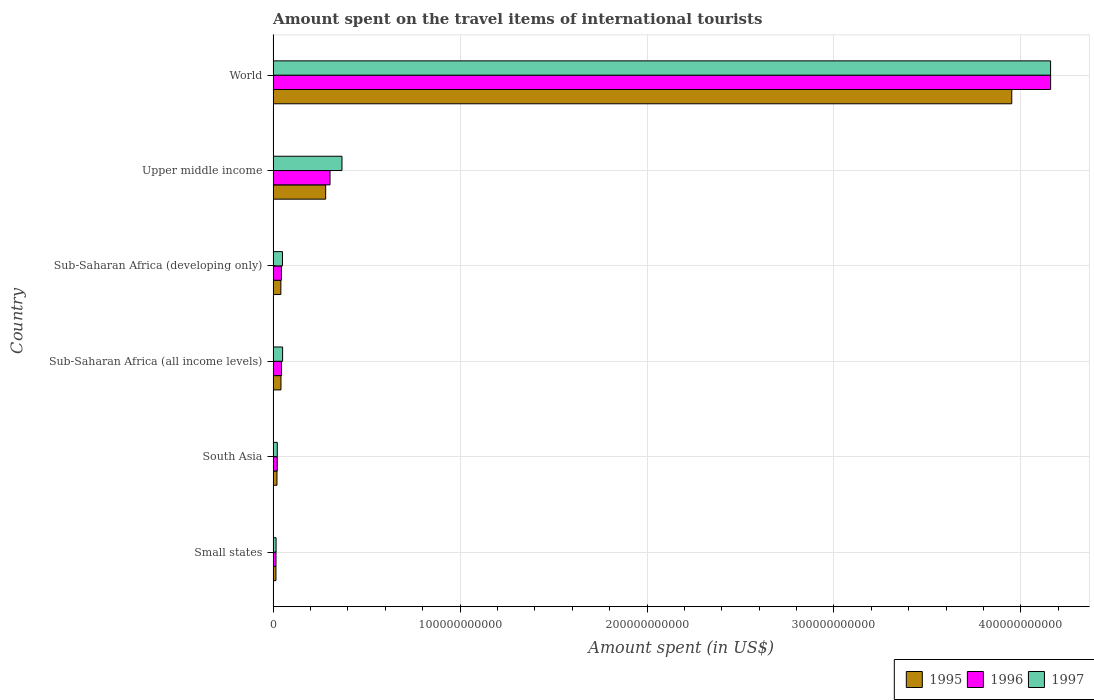How many different coloured bars are there?
Keep it short and to the point. 3. How many groups of bars are there?
Offer a very short reply. 6. Are the number of bars per tick equal to the number of legend labels?
Offer a very short reply. Yes. Are the number of bars on each tick of the Y-axis equal?
Keep it short and to the point. Yes. How many bars are there on the 1st tick from the bottom?
Offer a very short reply. 3. What is the label of the 2nd group of bars from the top?
Offer a terse response. Upper middle income. In how many cases, is the number of bars for a given country not equal to the number of legend labels?
Ensure brevity in your answer.  0. What is the amount spent on the travel items of international tourists in 1996 in World?
Provide a succinct answer. 4.16e+11. Across all countries, what is the maximum amount spent on the travel items of international tourists in 1997?
Offer a terse response. 4.16e+11. Across all countries, what is the minimum amount spent on the travel items of international tourists in 1997?
Your response must be concise. 1.58e+09. In which country was the amount spent on the travel items of international tourists in 1996 maximum?
Your response must be concise. World. In which country was the amount spent on the travel items of international tourists in 1996 minimum?
Make the answer very short. Small states. What is the total amount spent on the travel items of international tourists in 1997 in the graph?
Offer a terse response. 4.67e+11. What is the difference between the amount spent on the travel items of international tourists in 1996 in Small states and that in Sub-Saharan Africa (all income levels)?
Offer a very short reply. -2.96e+09. What is the difference between the amount spent on the travel items of international tourists in 1996 in South Asia and the amount spent on the travel items of international tourists in 1997 in World?
Provide a succinct answer. -4.14e+11. What is the average amount spent on the travel items of international tourists in 1996 per country?
Provide a succinct answer. 7.65e+1. What is the difference between the amount spent on the travel items of international tourists in 1995 and amount spent on the travel items of international tourists in 1996 in Upper middle income?
Your answer should be compact. -2.34e+09. In how many countries, is the amount spent on the travel items of international tourists in 1997 greater than 120000000000 US$?
Your answer should be very brief. 1. What is the ratio of the amount spent on the travel items of international tourists in 1997 in South Asia to that in Upper middle income?
Provide a succinct answer. 0.06. Is the amount spent on the travel items of international tourists in 1995 in South Asia less than that in Sub-Saharan Africa (all income levels)?
Your answer should be compact. Yes. Is the difference between the amount spent on the travel items of international tourists in 1995 in Sub-Saharan Africa (all income levels) and Upper middle income greater than the difference between the amount spent on the travel items of international tourists in 1996 in Sub-Saharan Africa (all income levels) and Upper middle income?
Keep it short and to the point. Yes. What is the difference between the highest and the second highest amount spent on the travel items of international tourists in 1997?
Offer a very short reply. 3.79e+11. What is the difference between the highest and the lowest amount spent on the travel items of international tourists in 1996?
Provide a succinct answer. 4.14e+11. Is the sum of the amount spent on the travel items of international tourists in 1997 in South Asia and World greater than the maximum amount spent on the travel items of international tourists in 1996 across all countries?
Your response must be concise. Yes. How many bars are there?
Provide a short and direct response. 18. How many countries are there in the graph?
Offer a very short reply. 6. What is the difference between two consecutive major ticks on the X-axis?
Your answer should be very brief. 1.00e+11. Are the values on the major ticks of X-axis written in scientific E-notation?
Offer a terse response. No. Does the graph contain grids?
Your answer should be very brief. Yes. How many legend labels are there?
Your answer should be compact. 3. How are the legend labels stacked?
Provide a succinct answer. Horizontal. What is the title of the graph?
Your answer should be very brief. Amount spent on the travel items of international tourists. Does "1998" appear as one of the legend labels in the graph?
Give a very brief answer. No. What is the label or title of the X-axis?
Offer a terse response. Amount spent (in US$). What is the Amount spent (in US$) in 1995 in Small states?
Provide a succinct answer. 1.51e+09. What is the Amount spent (in US$) in 1996 in Small states?
Provide a short and direct response. 1.54e+09. What is the Amount spent (in US$) of 1997 in Small states?
Provide a short and direct response. 1.58e+09. What is the Amount spent (in US$) of 1995 in South Asia?
Give a very brief answer. 2.06e+09. What is the Amount spent (in US$) in 1996 in South Asia?
Provide a short and direct response. 2.21e+09. What is the Amount spent (in US$) of 1997 in South Asia?
Offer a terse response. 2.23e+09. What is the Amount spent (in US$) of 1995 in Sub-Saharan Africa (all income levels)?
Ensure brevity in your answer.  4.20e+09. What is the Amount spent (in US$) in 1996 in Sub-Saharan Africa (all income levels)?
Provide a succinct answer. 4.50e+09. What is the Amount spent (in US$) in 1997 in Sub-Saharan Africa (all income levels)?
Your answer should be compact. 5.07e+09. What is the Amount spent (in US$) of 1995 in Sub-Saharan Africa (developing only)?
Offer a terse response. 4.14e+09. What is the Amount spent (in US$) in 1996 in Sub-Saharan Africa (developing only)?
Provide a short and direct response. 4.44e+09. What is the Amount spent (in US$) in 1997 in Sub-Saharan Africa (developing only)?
Offer a very short reply. 5.01e+09. What is the Amount spent (in US$) in 1995 in Upper middle income?
Offer a very short reply. 2.81e+1. What is the Amount spent (in US$) of 1996 in Upper middle income?
Offer a terse response. 3.04e+1. What is the Amount spent (in US$) of 1997 in Upper middle income?
Offer a terse response. 3.68e+1. What is the Amount spent (in US$) of 1995 in World?
Your answer should be compact. 3.95e+11. What is the Amount spent (in US$) of 1996 in World?
Offer a very short reply. 4.16e+11. What is the Amount spent (in US$) in 1997 in World?
Give a very brief answer. 4.16e+11. Across all countries, what is the maximum Amount spent (in US$) of 1995?
Provide a short and direct response. 3.95e+11. Across all countries, what is the maximum Amount spent (in US$) in 1996?
Offer a very short reply. 4.16e+11. Across all countries, what is the maximum Amount spent (in US$) in 1997?
Your response must be concise. 4.16e+11. Across all countries, what is the minimum Amount spent (in US$) in 1995?
Provide a short and direct response. 1.51e+09. Across all countries, what is the minimum Amount spent (in US$) in 1996?
Provide a succinct answer. 1.54e+09. Across all countries, what is the minimum Amount spent (in US$) of 1997?
Keep it short and to the point. 1.58e+09. What is the total Amount spent (in US$) in 1995 in the graph?
Keep it short and to the point. 4.35e+11. What is the total Amount spent (in US$) of 1996 in the graph?
Make the answer very short. 4.59e+11. What is the total Amount spent (in US$) in 1997 in the graph?
Ensure brevity in your answer.  4.67e+11. What is the difference between the Amount spent (in US$) of 1995 in Small states and that in South Asia?
Give a very brief answer. -5.48e+08. What is the difference between the Amount spent (in US$) of 1996 in Small states and that in South Asia?
Provide a short and direct response. -6.72e+08. What is the difference between the Amount spent (in US$) of 1997 in Small states and that in South Asia?
Make the answer very short. -6.45e+08. What is the difference between the Amount spent (in US$) in 1995 in Small states and that in Sub-Saharan Africa (all income levels)?
Your answer should be very brief. -2.69e+09. What is the difference between the Amount spent (in US$) of 1996 in Small states and that in Sub-Saharan Africa (all income levels)?
Provide a succinct answer. -2.96e+09. What is the difference between the Amount spent (in US$) in 1997 in Small states and that in Sub-Saharan Africa (all income levels)?
Your answer should be very brief. -3.49e+09. What is the difference between the Amount spent (in US$) in 1995 in Small states and that in Sub-Saharan Africa (developing only)?
Give a very brief answer. -2.63e+09. What is the difference between the Amount spent (in US$) of 1996 in Small states and that in Sub-Saharan Africa (developing only)?
Provide a short and direct response. -2.90e+09. What is the difference between the Amount spent (in US$) in 1997 in Small states and that in Sub-Saharan Africa (developing only)?
Your answer should be compact. -3.42e+09. What is the difference between the Amount spent (in US$) of 1995 in Small states and that in Upper middle income?
Your answer should be compact. -2.66e+1. What is the difference between the Amount spent (in US$) in 1996 in Small states and that in Upper middle income?
Provide a succinct answer. -2.89e+1. What is the difference between the Amount spent (in US$) of 1997 in Small states and that in Upper middle income?
Give a very brief answer. -3.53e+1. What is the difference between the Amount spent (in US$) in 1995 in Small states and that in World?
Give a very brief answer. -3.94e+11. What is the difference between the Amount spent (in US$) in 1996 in Small states and that in World?
Offer a very short reply. -4.14e+11. What is the difference between the Amount spent (in US$) of 1997 in Small states and that in World?
Your response must be concise. -4.14e+11. What is the difference between the Amount spent (in US$) of 1995 in South Asia and that in Sub-Saharan Africa (all income levels)?
Give a very brief answer. -2.14e+09. What is the difference between the Amount spent (in US$) of 1996 in South Asia and that in Sub-Saharan Africa (all income levels)?
Provide a short and direct response. -2.29e+09. What is the difference between the Amount spent (in US$) of 1997 in South Asia and that in Sub-Saharan Africa (all income levels)?
Your answer should be compact. -2.85e+09. What is the difference between the Amount spent (in US$) in 1995 in South Asia and that in Sub-Saharan Africa (developing only)?
Keep it short and to the point. -2.08e+09. What is the difference between the Amount spent (in US$) in 1996 in South Asia and that in Sub-Saharan Africa (developing only)?
Offer a very short reply. -2.23e+09. What is the difference between the Amount spent (in US$) of 1997 in South Asia and that in Sub-Saharan Africa (developing only)?
Your answer should be very brief. -2.78e+09. What is the difference between the Amount spent (in US$) of 1995 in South Asia and that in Upper middle income?
Make the answer very short. -2.61e+1. What is the difference between the Amount spent (in US$) of 1996 in South Asia and that in Upper middle income?
Your answer should be compact. -2.82e+1. What is the difference between the Amount spent (in US$) in 1997 in South Asia and that in Upper middle income?
Your answer should be compact. -3.46e+1. What is the difference between the Amount spent (in US$) in 1995 in South Asia and that in World?
Provide a succinct answer. -3.93e+11. What is the difference between the Amount spent (in US$) of 1996 in South Asia and that in World?
Provide a succinct answer. -4.14e+11. What is the difference between the Amount spent (in US$) in 1997 in South Asia and that in World?
Provide a short and direct response. -4.14e+11. What is the difference between the Amount spent (in US$) in 1995 in Sub-Saharan Africa (all income levels) and that in Sub-Saharan Africa (developing only)?
Provide a short and direct response. 5.93e+07. What is the difference between the Amount spent (in US$) of 1996 in Sub-Saharan Africa (all income levels) and that in Sub-Saharan Africa (developing only)?
Your answer should be very brief. 6.18e+07. What is the difference between the Amount spent (in US$) of 1997 in Sub-Saharan Africa (all income levels) and that in Sub-Saharan Africa (developing only)?
Offer a terse response. 6.67e+07. What is the difference between the Amount spent (in US$) of 1995 in Sub-Saharan Africa (all income levels) and that in Upper middle income?
Provide a succinct answer. -2.39e+1. What is the difference between the Amount spent (in US$) in 1996 in Sub-Saharan Africa (all income levels) and that in Upper middle income?
Offer a very short reply. -2.59e+1. What is the difference between the Amount spent (in US$) of 1997 in Sub-Saharan Africa (all income levels) and that in Upper middle income?
Keep it short and to the point. -3.18e+1. What is the difference between the Amount spent (in US$) of 1995 in Sub-Saharan Africa (all income levels) and that in World?
Your answer should be very brief. -3.91e+11. What is the difference between the Amount spent (in US$) in 1996 in Sub-Saharan Africa (all income levels) and that in World?
Make the answer very short. -4.11e+11. What is the difference between the Amount spent (in US$) of 1997 in Sub-Saharan Africa (all income levels) and that in World?
Offer a terse response. -4.11e+11. What is the difference between the Amount spent (in US$) of 1995 in Sub-Saharan Africa (developing only) and that in Upper middle income?
Your answer should be very brief. -2.40e+1. What is the difference between the Amount spent (in US$) in 1996 in Sub-Saharan Africa (developing only) and that in Upper middle income?
Ensure brevity in your answer.  -2.60e+1. What is the difference between the Amount spent (in US$) of 1997 in Sub-Saharan Africa (developing only) and that in Upper middle income?
Give a very brief answer. -3.18e+1. What is the difference between the Amount spent (in US$) in 1995 in Sub-Saharan Africa (developing only) and that in World?
Keep it short and to the point. -3.91e+11. What is the difference between the Amount spent (in US$) in 1996 in Sub-Saharan Africa (developing only) and that in World?
Keep it short and to the point. -4.11e+11. What is the difference between the Amount spent (in US$) of 1997 in Sub-Saharan Africa (developing only) and that in World?
Give a very brief answer. -4.11e+11. What is the difference between the Amount spent (in US$) in 1995 in Upper middle income and that in World?
Keep it short and to the point. -3.67e+11. What is the difference between the Amount spent (in US$) in 1996 in Upper middle income and that in World?
Your answer should be very brief. -3.85e+11. What is the difference between the Amount spent (in US$) in 1997 in Upper middle income and that in World?
Offer a very short reply. -3.79e+11. What is the difference between the Amount spent (in US$) in 1995 in Small states and the Amount spent (in US$) in 1996 in South Asia?
Keep it short and to the point. -7.03e+08. What is the difference between the Amount spent (in US$) of 1995 in Small states and the Amount spent (in US$) of 1997 in South Asia?
Provide a succinct answer. -7.17e+08. What is the difference between the Amount spent (in US$) of 1996 in Small states and the Amount spent (in US$) of 1997 in South Asia?
Your response must be concise. -6.86e+08. What is the difference between the Amount spent (in US$) in 1995 in Small states and the Amount spent (in US$) in 1996 in Sub-Saharan Africa (all income levels)?
Your response must be concise. -2.99e+09. What is the difference between the Amount spent (in US$) of 1995 in Small states and the Amount spent (in US$) of 1997 in Sub-Saharan Africa (all income levels)?
Ensure brevity in your answer.  -3.56e+09. What is the difference between the Amount spent (in US$) in 1996 in Small states and the Amount spent (in US$) in 1997 in Sub-Saharan Africa (all income levels)?
Make the answer very short. -3.53e+09. What is the difference between the Amount spent (in US$) in 1995 in Small states and the Amount spent (in US$) in 1996 in Sub-Saharan Africa (developing only)?
Provide a succinct answer. -2.93e+09. What is the difference between the Amount spent (in US$) in 1995 in Small states and the Amount spent (in US$) in 1997 in Sub-Saharan Africa (developing only)?
Keep it short and to the point. -3.50e+09. What is the difference between the Amount spent (in US$) of 1996 in Small states and the Amount spent (in US$) of 1997 in Sub-Saharan Africa (developing only)?
Keep it short and to the point. -3.46e+09. What is the difference between the Amount spent (in US$) in 1995 in Small states and the Amount spent (in US$) in 1996 in Upper middle income?
Offer a very short reply. -2.89e+1. What is the difference between the Amount spent (in US$) in 1995 in Small states and the Amount spent (in US$) in 1997 in Upper middle income?
Ensure brevity in your answer.  -3.53e+1. What is the difference between the Amount spent (in US$) of 1996 in Small states and the Amount spent (in US$) of 1997 in Upper middle income?
Keep it short and to the point. -3.53e+1. What is the difference between the Amount spent (in US$) of 1995 in Small states and the Amount spent (in US$) of 1996 in World?
Offer a very short reply. -4.14e+11. What is the difference between the Amount spent (in US$) in 1995 in Small states and the Amount spent (in US$) in 1997 in World?
Give a very brief answer. -4.14e+11. What is the difference between the Amount spent (in US$) in 1996 in Small states and the Amount spent (in US$) in 1997 in World?
Offer a very short reply. -4.14e+11. What is the difference between the Amount spent (in US$) of 1995 in South Asia and the Amount spent (in US$) of 1996 in Sub-Saharan Africa (all income levels)?
Keep it short and to the point. -2.44e+09. What is the difference between the Amount spent (in US$) of 1995 in South Asia and the Amount spent (in US$) of 1997 in Sub-Saharan Africa (all income levels)?
Your response must be concise. -3.01e+09. What is the difference between the Amount spent (in US$) in 1996 in South Asia and the Amount spent (in US$) in 1997 in Sub-Saharan Africa (all income levels)?
Offer a terse response. -2.86e+09. What is the difference between the Amount spent (in US$) in 1995 in South Asia and the Amount spent (in US$) in 1996 in Sub-Saharan Africa (developing only)?
Offer a terse response. -2.38e+09. What is the difference between the Amount spent (in US$) in 1995 in South Asia and the Amount spent (in US$) in 1997 in Sub-Saharan Africa (developing only)?
Make the answer very short. -2.95e+09. What is the difference between the Amount spent (in US$) in 1996 in South Asia and the Amount spent (in US$) in 1997 in Sub-Saharan Africa (developing only)?
Your answer should be very brief. -2.79e+09. What is the difference between the Amount spent (in US$) of 1995 in South Asia and the Amount spent (in US$) of 1996 in Upper middle income?
Make the answer very short. -2.84e+1. What is the difference between the Amount spent (in US$) in 1995 in South Asia and the Amount spent (in US$) in 1997 in Upper middle income?
Make the answer very short. -3.48e+1. What is the difference between the Amount spent (in US$) in 1996 in South Asia and the Amount spent (in US$) in 1997 in Upper middle income?
Keep it short and to the point. -3.46e+1. What is the difference between the Amount spent (in US$) in 1995 in South Asia and the Amount spent (in US$) in 1996 in World?
Offer a very short reply. -4.14e+11. What is the difference between the Amount spent (in US$) of 1995 in South Asia and the Amount spent (in US$) of 1997 in World?
Ensure brevity in your answer.  -4.14e+11. What is the difference between the Amount spent (in US$) of 1996 in South Asia and the Amount spent (in US$) of 1997 in World?
Your response must be concise. -4.14e+11. What is the difference between the Amount spent (in US$) in 1995 in Sub-Saharan Africa (all income levels) and the Amount spent (in US$) in 1996 in Sub-Saharan Africa (developing only)?
Your answer should be very brief. -2.40e+08. What is the difference between the Amount spent (in US$) of 1995 in Sub-Saharan Africa (all income levels) and the Amount spent (in US$) of 1997 in Sub-Saharan Africa (developing only)?
Your response must be concise. -8.08e+08. What is the difference between the Amount spent (in US$) in 1996 in Sub-Saharan Africa (all income levels) and the Amount spent (in US$) in 1997 in Sub-Saharan Africa (developing only)?
Keep it short and to the point. -5.05e+08. What is the difference between the Amount spent (in US$) of 1995 in Sub-Saharan Africa (all income levels) and the Amount spent (in US$) of 1996 in Upper middle income?
Your answer should be very brief. -2.62e+1. What is the difference between the Amount spent (in US$) of 1995 in Sub-Saharan Africa (all income levels) and the Amount spent (in US$) of 1997 in Upper middle income?
Ensure brevity in your answer.  -3.26e+1. What is the difference between the Amount spent (in US$) of 1996 in Sub-Saharan Africa (all income levels) and the Amount spent (in US$) of 1997 in Upper middle income?
Your response must be concise. -3.23e+1. What is the difference between the Amount spent (in US$) of 1995 in Sub-Saharan Africa (all income levels) and the Amount spent (in US$) of 1996 in World?
Provide a succinct answer. -4.12e+11. What is the difference between the Amount spent (in US$) in 1995 in Sub-Saharan Africa (all income levels) and the Amount spent (in US$) in 1997 in World?
Your answer should be compact. -4.12e+11. What is the difference between the Amount spent (in US$) in 1996 in Sub-Saharan Africa (all income levels) and the Amount spent (in US$) in 1997 in World?
Your response must be concise. -4.11e+11. What is the difference between the Amount spent (in US$) in 1995 in Sub-Saharan Africa (developing only) and the Amount spent (in US$) in 1996 in Upper middle income?
Your answer should be very brief. -2.63e+1. What is the difference between the Amount spent (in US$) of 1995 in Sub-Saharan Africa (developing only) and the Amount spent (in US$) of 1997 in Upper middle income?
Ensure brevity in your answer.  -3.27e+1. What is the difference between the Amount spent (in US$) in 1996 in Sub-Saharan Africa (developing only) and the Amount spent (in US$) in 1997 in Upper middle income?
Make the answer very short. -3.24e+1. What is the difference between the Amount spent (in US$) of 1995 in Sub-Saharan Africa (developing only) and the Amount spent (in US$) of 1996 in World?
Offer a very short reply. -4.12e+11. What is the difference between the Amount spent (in US$) in 1995 in Sub-Saharan Africa (developing only) and the Amount spent (in US$) in 1997 in World?
Give a very brief answer. -4.12e+11. What is the difference between the Amount spent (in US$) of 1996 in Sub-Saharan Africa (developing only) and the Amount spent (in US$) of 1997 in World?
Provide a short and direct response. -4.11e+11. What is the difference between the Amount spent (in US$) in 1995 in Upper middle income and the Amount spent (in US$) in 1996 in World?
Make the answer very short. -3.88e+11. What is the difference between the Amount spent (in US$) in 1995 in Upper middle income and the Amount spent (in US$) in 1997 in World?
Ensure brevity in your answer.  -3.88e+11. What is the difference between the Amount spent (in US$) in 1996 in Upper middle income and the Amount spent (in US$) in 1997 in World?
Ensure brevity in your answer.  -3.85e+11. What is the average Amount spent (in US$) in 1995 per country?
Give a very brief answer. 7.25e+1. What is the average Amount spent (in US$) of 1996 per country?
Your answer should be compact. 7.65e+1. What is the average Amount spent (in US$) in 1997 per country?
Provide a succinct answer. 7.78e+1. What is the difference between the Amount spent (in US$) in 1995 and Amount spent (in US$) in 1996 in Small states?
Provide a short and direct response. -3.15e+07. What is the difference between the Amount spent (in US$) of 1995 and Amount spent (in US$) of 1997 in Small states?
Your response must be concise. -7.24e+07. What is the difference between the Amount spent (in US$) in 1996 and Amount spent (in US$) in 1997 in Small states?
Keep it short and to the point. -4.09e+07. What is the difference between the Amount spent (in US$) of 1995 and Amount spent (in US$) of 1996 in South Asia?
Offer a terse response. -1.55e+08. What is the difference between the Amount spent (in US$) of 1995 and Amount spent (in US$) of 1997 in South Asia?
Keep it short and to the point. -1.69e+08. What is the difference between the Amount spent (in US$) of 1996 and Amount spent (in US$) of 1997 in South Asia?
Provide a succinct answer. -1.42e+07. What is the difference between the Amount spent (in US$) of 1995 and Amount spent (in US$) of 1996 in Sub-Saharan Africa (all income levels)?
Make the answer very short. -3.02e+08. What is the difference between the Amount spent (in US$) in 1995 and Amount spent (in US$) in 1997 in Sub-Saharan Africa (all income levels)?
Keep it short and to the point. -8.74e+08. What is the difference between the Amount spent (in US$) in 1996 and Amount spent (in US$) in 1997 in Sub-Saharan Africa (all income levels)?
Ensure brevity in your answer.  -5.72e+08. What is the difference between the Amount spent (in US$) of 1995 and Amount spent (in US$) of 1996 in Sub-Saharan Africa (developing only)?
Your response must be concise. -3.00e+08. What is the difference between the Amount spent (in US$) of 1995 and Amount spent (in US$) of 1997 in Sub-Saharan Africa (developing only)?
Your answer should be very brief. -8.67e+08. What is the difference between the Amount spent (in US$) of 1996 and Amount spent (in US$) of 1997 in Sub-Saharan Africa (developing only)?
Your response must be concise. -5.67e+08. What is the difference between the Amount spent (in US$) in 1995 and Amount spent (in US$) in 1996 in Upper middle income?
Make the answer very short. -2.34e+09. What is the difference between the Amount spent (in US$) in 1995 and Amount spent (in US$) in 1997 in Upper middle income?
Offer a terse response. -8.72e+09. What is the difference between the Amount spent (in US$) of 1996 and Amount spent (in US$) of 1997 in Upper middle income?
Provide a succinct answer. -6.39e+09. What is the difference between the Amount spent (in US$) of 1995 and Amount spent (in US$) of 1996 in World?
Your answer should be very brief. -2.08e+1. What is the difference between the Amount spent (in US$) in 1995 and Amount spent (in US$) in 1997 in World?
Your answer should be very brief. -2.08e+1. What is the difference between the Amount spent (in US$) of 1996 and Amount spent (in US$) of 1997 in World?
Ensure brevity in your answer.  1.91e+07. What is the ratio of the Amount spent (in US$) of 1995 in Small states to that in South Asia?
Provide a short and direct response. 0.73. What is the ratio of the Amount spent (in US$) in 1996 in Small states to that in South Asia?
Ensure brevity in your answer.  0.7. What is the ratio of the Amount spent (in US$) of 1997 in Small states to that in South Asia?
Keep it short and to the point. 0.71. What is the ratio of the Amount spent (in US$) of 1995 in Small states to that in Sub-Saharan Africa (all income levels)?
Provide a short and direct response. 0.36. What is the ratio of the Amount spent (in US$) of 1996 in Small states to that in Sub-Saharan Africa (all income levels)?
Provide a succinct answer. 0.34. What is the ratio of the Amount spent (in US$) of 1997 in Small states to that in Sub-Saharan Africa (all income levels)?
Ensure brevity in your answer.  0.31. What is the ratio of the Amount spent (in US$) of 1995 in Small states to that in Sub-Saharan Africa (developing only)?
Your response must be concise. 0.36. What is the ratio of the Amount spent (in US$) of 1996 in Small states to that in Sub-Saharan Africa (developing only)?
Keep it short and to the point. 0.35. What is the ratio of the Amount spent (in US$) of 1997 in Small states to that in Sub-Saharan Africa (developing only)?
Offer a terse response. 0.32. What is the ratio of the Amount spent (in US$) in 1995 in Small states to that in Upper middle income?
Your answer should be very brief. 0.05. What is the ratio of the Amount spent (in US$) of 1996 in Small states to that in Upper middle income?
Keep it short and to the point. 0.05. What is the ratio of the Amount spent (in US$) of 1997 in Small states to that in Upper middle income?
Provide a succinct answer. 0.04. What is the ratio of the Amount spent (in US$) in 1995 in Small states to that in World?
Offer a very short reply. 0. What is the ratio of the Amount spent (in US$) of 1996 in Small states to that in World?
Keep it short and to the point. 0. What is the ratio of the Amount spent (in US$) of 1997 in Small states to that in World?
Ensure brevity in your answer.  0. What is the ratio of the Amount spent (in US$) of 1995 in South Asia to that in Sub-Saharan Africa (all income levels)?
Give a very brief answer. 0.49. What is the ratio of the Amount spent (in US$) of 1996 in South Asia to that in Sub-Saharan Africa (all income levels)?
Offer a very short reply. 0.49. What is the ratio of the Amount spent (in US$) of 1997 in South Asia to that in Sub-Saharan Africa (all income levels)?
Provide a short and direct response. 0.44. What is the ratio of the Amount spent (in US$) in 1995 in South Asia to that in Sub-Saharan Africa (developing only)?
Your answer should be very brief. 0.5. What is the ratio of the Amount spent (in US$) of 1996 in South Asia to that in Sub-Saharan Africa (developing only)?
Make the answer very short. 0.5. What is the ratio of the Amount spent (in US$) in 1997 in South Asia to that in Sub-Saharan Africa (developing only)?
Offer a very short reply. 0.45. What is the ratio of the Amount spent (in US$) in 1995 in South Asia to that in Upper middle income?
Keep it short and to the point. 0.07. What is the ratio of the Amount spent (in US$) in 1996 in South Asia to that in Upper middle income?
Your answer should be very brief. 0.07. What is the ratio of the Amount spent (in US$) of 1997 in South Asia to that in Upper middle income?
Make the answer very short. 0.06. What is the ratio of the Amount spent (in US$) of 1995 in South Asia to that in World?
Make the answer very short. 0.01. What is the ratio of the Amount spent (in US$) of 1996 in South Asia to that in World?
Your answer should be compact. 0.01. What is the ratio of the Amount spent (in US$) of 1997 in South Asia to that in World?
Give a very brief answer. 0.01. What is the ratio of the Amount spent (in US$) in 1995 in Sub-Saharan Africa (all income levels) to that in Sub-Saharan Africa (developing only)?
Ensure brevity in your answer.  1.01. What is the ratio of the Amount spent (in US$) in 1996 in Sub-Saharan Africa (all income levels) to that in Sub-Saharan Africa (developing only)?
Your answer should be very brief. 1.01. What is the ratio of the Amount spent (in US$) of 1997 in Sub-Saharan Africa (all income levels) to that in Sub-Saharan Africa (developing only)?
Keep it short and to the point. 1.01. What is the ratio of the Amount spent (in US$) of 1995 in Sub-Saharan Africa (all income levels) to that in Upper middle income?
Your answer should be compact. 0.15. What is the ratio of the Amount spent (in US$) in 1996 in Sub-Saharan Africa (all income levels) to that in Upper middle income?
Give a very brief answer. 0.15. What is the ratio of the Amount spent (in US$) of 1997 in Sub-Saharan Africa (all income levels) to that in Upper middle income?
Ensure brevity in your answer.  0.14. What is the ratio of the Amount spent (in US$) of 1995 in Sub-Saharan Africa (all income levels) to that in World?
Give a very brief answer. 0.01. What is the ratio of the Amount spent (in US$) of 1996 in Sub-Saharan Africa (all income levels) to that in World?
Your answer should be compact. 0.01. What is the ratio of the Amount spent (in US$) of 1997 in Sub-Saharan Africa (all income levels) to that in World?
Offer a very short reply. 0.01. What is the ratio of the Amount spent (in US$) in 1995 in Sub-Saharan Africa (developing only) to that in Upper middle income?
Give a very brief answer. 0.15. What is the ratio of the Amount spent (in US$) of 1996 in Sub-Saharan Africa (developing only) to that in Upper middle income?
Keep it short and to the point. 0.15. What is the ratio of the Amount spent (in US$) in 1997 in Sub-Saharan Africa (developing only) to that in Upper middle income?
Your answer should be compact. 0.14. What is the ratio of the Amount spent (in US$) of 1995 in Sub-Saharan Africa (developing only) to that in World?
Keep it short and to the point. 0.01. What is the ratio of the Amount spent (in US$) in 1996 in Sub-Saharan Africa (developing only) to that in World?
Provide a succinct answer. 0.01. What is the ratio of the Amount spent (in US$) in 1997 in Sub-Saharan Africa (developing only) to that in World?
Provide a succinct answer. 0.01. What is the ratio of the Amount spent (in US$) in 1995 in Upper middle income to that in World?
Make the answer very short. 0.07. What is the ratio of the Amount spent (in US$) in 1996 in Upper middle income to that in World?
Give a very brief answer. 0.07. What is the ratio of the Amount spent (in US$) of 1997 in Upper middle income to that in World?
Your response must be concise. 0.09. What is the difference between the highest and the second highest Amount spent (in US$) of 1995?
Your answer should be very brief. 3.67e+11. What is the difference between the highest and the second highest Amount spent (in US$) in 1996?
Provide a short and direct response. 3.85e+11. What is the difference between the highest and the second highest Amount spent (in US$) in 1997?
Provide a succinct answer. 3.79e+11. What is the difference between the highest and the lowest Amount spent (in US$) in 1995?
Provide a short and direct response. 3.94e+11. What is the difference between the highest and the lowest Amount spent (in US$) in 1996?
Provide a succinct answer. 4.14e+11. What is the difference between the highest and the lowest Amount spent (in US$) in 1997?
Your answer should be compact. 4.14e+11. 